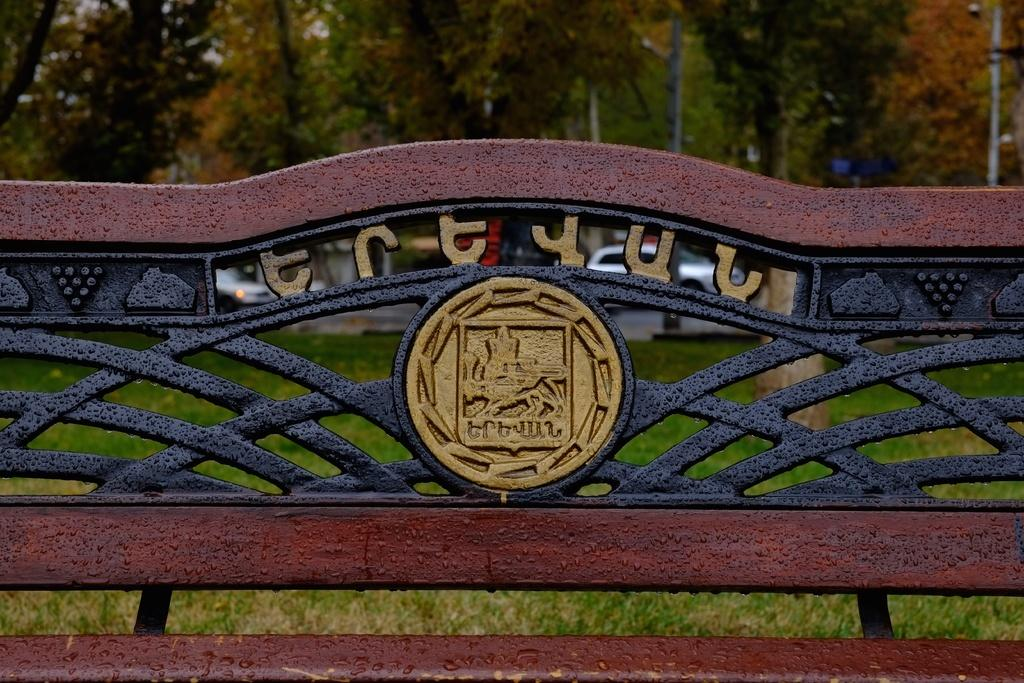What type of bench is in the image? There is an iron bench in the image. What type of ground surface is visible in the image? There is grass visible in the image. What type of transportation can be seen in the image? There are vehicles in the image. What type of vegetation is present in the image? There are trees in the image. What type of desk is visible in the image? There is no desk present in the image. How does the fact contribute to the image? The question is irrelevant, as there is no mention of a fact in the image. 